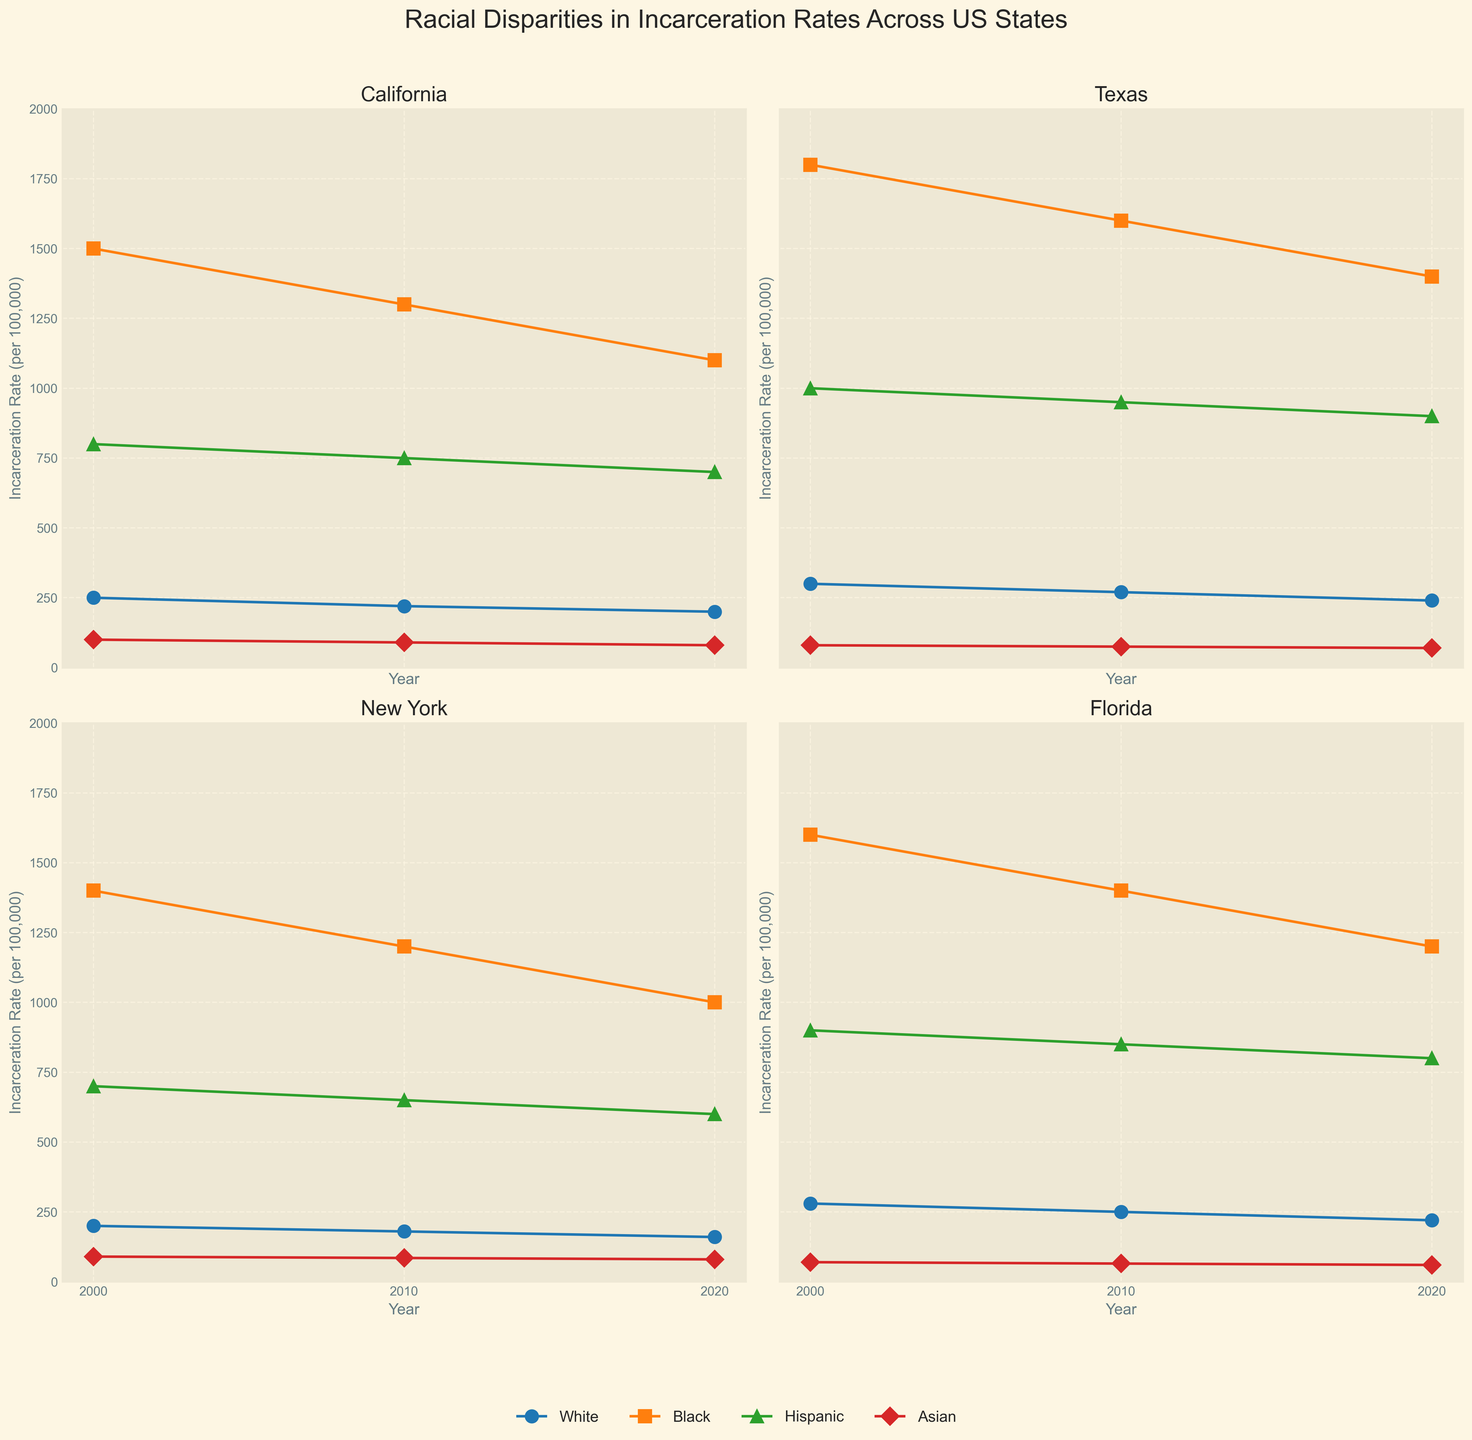What is the title of the figure? The figure's title is prominently displayed at the top and reads 'Racial Disparities in Incarceration Rates Across US States'.
Answer: Racial Disparities in Incarceration Rates Across US States How are the states represented in the figure? Each subplot represents a different state, with the states being California, Texas, New York, and Florida.
Answer: California, Texas, New York, and Florida What is the range on the Y-axis? The Y-axis range is consistent across all subplots, spanning from 0 to 2000 incarceration rates.
Answer: 0 to 2000 Which state showed the greatest decrease in Black incarceration rates from 2000 to 2020? Upon visual inspection, California showed a significant decrease in Black incarceration rates, dropping from 1500 in 2000 to 1100 in 2020.
Answer: California How do the incarceration rates for Asian individuals compare between states in 2010? In 2010, the incarceration rates for Asian individuals were 90 in California, 75 in Texas, 85 in New York, and 65 in Florida.
Answer: California: 90, Texas: 75, New York: 85, Florida: 65 Which race consistently had the highest incarceration rates across all states and years? Black individuals consistently had the highest incarceration rates across all states and years, as evident by the topmost data points in each subplot.
Answer: Black What is the trend for Hispanic incarceration rates in New York from 2000 to 2020? The plots indicate a decrease in Hispanic incarceration rates in New York from 700 in 2000 to 600 in 2020.
Answer: Decreasing Between Texas and Florida, which state had higher Hispanic incarceration rates in the year 2020? In 2020, Texas had a higher Hispanic incarceration rate (900) compared to Florida (800).
Answer: Texas What color is used to represent the White population in the figure? The White population is represented using a shade of blue in the plots.
Answer: Blue Compare the trends in incarceration rates for White individuals in California and New York from 2000 to 2020. In California, White incarceration rates decreased from 250 in 2000 to 200 in 2020. In New York, the rates decreased from 200 in 2000 to 160 in 2020, both showing a downward trend.
Answer: Both showed a decreasing trend 